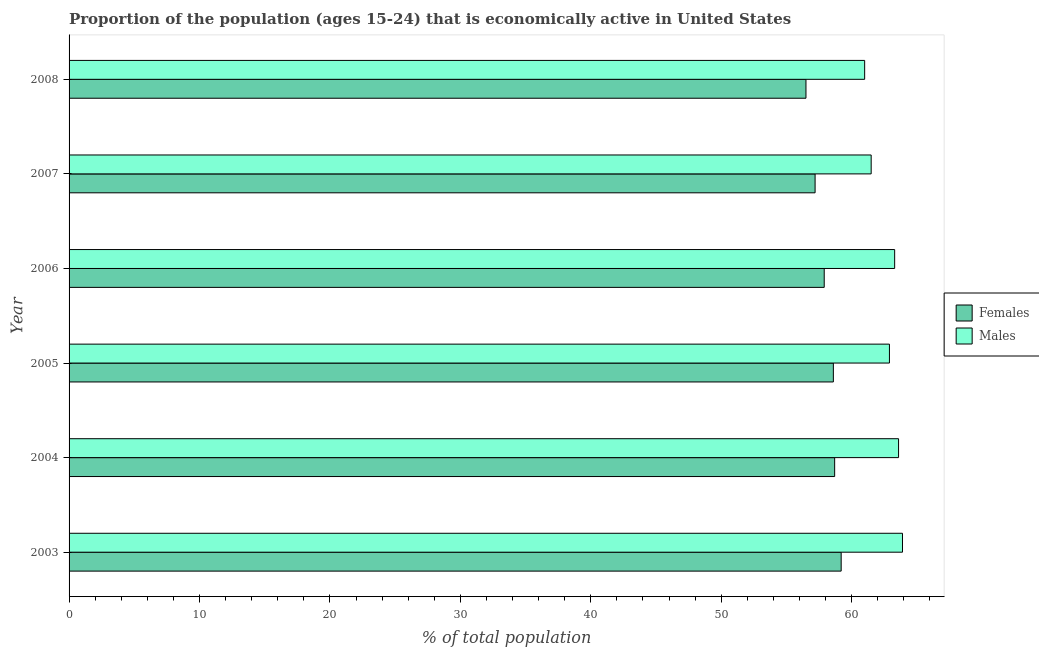How many different coloured bars are there?
Provide a short and direct response. 2. What is the percentage of economically active female population in 2005?
Your response must be concise. 58.6. Across all years, what is the maximum percentage of economically active male population?
Make the answer very short. 63.9. What is the total percentage of economically active female population in the graph?
Provide a succinct answer. 348.1. What is the difference between the percentage of economically active male population in 2006 and that in 2008?
Your response must be concise. 2.3. What is the average percentage of economically active male population per year?
Keep it short and to the point. 62.7. In the year 2006, what is the difference between the percentage of economically active male population and percentage of economically active female population?
Your answer should be compact. 5.4. What is the ratio of the percentage of economically active male population in 2004 to that in 2006?
Make the answer very short. 1. Is the percentage of economically active female population in 2003 less than that in 2005?
Provide a succinct answer. No. What is the difference between the highest and the second highest percentage of economically active female population?
Offer a very short reply. 0.5. What is the difference between the highest and the lowest percentage of economically active female population?
Make the answer very short. 2.7. What does the 1st bar from the top in 2004 represents?
Keep it short and to the point. Males. What does the 2nd bar from the bottom in 2003 represents?
Offer a very short reply. Males. How many bars are there?
Ensure brevity in your answer.  12. Are the values on the major ticks of X-axis written in scientific E-notation?
Your response must be concise. No. What is the title of the graph?
Make the answer very short. Proportion of the population (ages 15-24) that is economically active in United States. Does "Private credit bureau" appear as one of the legend labels in the graph?
Your response must be concise. No. What is the label or title of the X-axis?
Your answer should be compact. % of total population. What is the label or title of the Y-axis?
Ensure brevity in your answer.  Year. What is the % of total population of Females in 2003?
Your response must be concise. 59.2. What is the % of total population of Males in 2003?
Your answer should be very brief. 63.9. What is the % of total population in Females in 2004?
Ensure brevity in your answer.  58.7. What is the % of total population in Males in 2004?
Provide a succinct answer. 63.6. What is the % of total population in Females in 2005?
Offer a terse response. 58.6. What is the % of total population in Males in 2005?
Your answer should be very brief. 62.9. What is the % of total population in Females in 2006?
Your answer should be compact. 57.9. What is the % of total population in Males in 2006?
Provide a short and direct response. 63.3. What is the % of total population of Females in 2007?
Provide a short and direct response. 57.2. What is the % of total population of Males in 2007?
Give a very brief answer. 61.5. What is the % of total population of Females in 2008?
Keep it short and to the point. 56.5. Across all years, what is the maximum % of total population in Females?
Provide a succinct answer. 59.2. Across all years, what is the maximum % of total population of Males?
Your answer should be compact. 63.9. Across all years, what is the minimum % of total population in Females?
Your answer should be compact. 56.5. What is the total % of total population of Females in the graph?
Offer a terse response. 348.1. What is the total % of total population of Males in the graph?
Offer a very short reply. 376.2. What is the difference between the % of total population in Males in 2003 and that in 2004?
Ensure brevity in your answer.  0.3. What is the difference between the % of total population in Males in 2003 and that in 2005?
Your answer should be compact. 1. What is the difference between the % of total population of Females in 2003 and that in 2006?
Provide a short and direct response. 1.3. What is the difference between the % of total population of Males in 2003 and that in 2006?
Your answer should be compact. 0.6. What is the difference between the % of total population in Females in 2003 and that in 2007?
Your answer should be very brief. 2. What is the difference between the % of total population of Males in 2003 and that in 2007?
Provide a short and direct response. 2.4. What is the difference between the % of total population in Males in 2003 and that in 2008?
Your answer should be very brief. 2.9. What is the difference between the % of total population in Females in 2004 and that in 2005?
Your answer should be very brief. 0.1. What is the difference between the % of total population in Males in 2004 and that in 2005?
Your response must be concise. 0.7. What is the difference between the % of total population in Females in 2004 and that in 2007?
Provide a short and direct response. 1.5. What is the difference between the % of total population of Females in 2005 and that in 2008?
Offer a terse response. 2.1. What is the difference between the % of total population in Females in 2006 and that in 2007?
Provide a short and direct response. 0.7. What is the difference between the % of total population in Males in 2006 and that in 2007?
Your answer should be compact. 1.8. What is the difference between the % of total population in Females in 2006 and that in 2008?
Offer a terse response. 1.4. What is the difference between the % of total population of Males in 2007 and that in 2008?
Provide a succinct answer. 0.5. What is the difference between the % of total population of Females in 2003 and the % of total population of Males in 2004?
Your answer should be very brief. -4.4. What is the difference between the % of total population of Females in 2003 and the % of total population of Males in 2006?
Your response must be concise. -4.1. What is the difference between the % of total population in Females in 2003 and the % of total population in Males in 2007?
Ensure brevity in your answer.  -2.3. What is the difference between the % of total population of Females in 2004 and the % of total population of Males in 2005?
Your answer should be compact. -4.2. What is the difference between the % of total population of Females in 2004 and the % of total population of Males in 2007?
Your answer should be compact. -2.8. What is the difference between the % of total population in Females in 2004 and the % of total population in Males in 2008?
Offer a very short reply. -2.3. What is the difference between the % of total population of Females in 2005 and the % of total population of Males in 2006?
Keep it short and to the point. -4.7. What is the difference between the % of total population in Females in 2005 and the % of total population in Males in 2007?
Give a very brief answer. -2.9. What is the difference between the % of total population of Females in 2005 and the % of total population of Males in 2008?
Give a very brief answer. -2.4. What is the difference between the % of total population in Females in 2006 and the % of total population in Males in 2008?
Your answer should be very brief. -3.1. What is the difference between the % of total population of Females in 2007 and the % of total population of Males in 2008?
Give a very brief answer. -3.8. What is the average % of total population in Females per year?
Give a very brief answer. 58.02. What is the average % of total population in Males per year?
Offer a very short reply. 62.7. In the year 2003, what is the difference between the % of total population of Females and % of total population of Males?
Offer a very short reply. -4.7. In the year 2004, what is the difference between the % of total population in Females and % of total population in Males?
Offer a terse response. -4.9. In the year 2008, what is the difference between the % of total population in Females and % of total population in Males?
Offer a terse response. -4.5. What is the ratio of the % of total population of Females in 2003 to that in 2004?
Ensure brevity in your answer.  1.01. What is the ratio of the % of total population of Females in 2003 to that in 2005?
Offer a terse response. 1.01. What is the ratio of the % of total population in Males in 2003 to that in 2005?
Give a very brief answer. 1.02. What is the ratio of the % of total population in Females in 2003 to that in 2006?
Your response must be concise. 1.02. What is the ratio of the % of total population in Males in 2003 to that in 2006?
Your answer should be very brief. 1.01. What is the ratio of the % of total population of Females in 2003 to that in 2007?
Your answer should be very brief. 1.03. What is the ratio of the % of total population in Males in 2003 to that in 2007?
Offer a terse response. 1.04. What is the ratio of the % of total population of Females in 2003 to that in 2008?
Keep it short and to the point. 1.05. What is the ratio of the % of total population of Males in 2003 to that in 2008?
Make the answer very short. 1.05. What is the ratio of the % of total population of Females in 2004 to that in 2005?
Your answer should be very brief. 1. What is the ratio of the % of total population in Males in 2004 to that in 2005?
Your answer should be compact. 1.01. What is the ratio of the % of total population of Females in 2004 to that in 2006?
Offer a very short reply. 1.01. What is the ratio of the % of total population of Males in 2004 to that in 2006?
Offer a very short reply. 1. What is the ratio of the % of total population in Females in 2004 to that in 2007?
Offer a very short reply. 1.03. What is the ratio of the % of total population of Males in 2004 to that in 2007?
Your answer should be very brief. 1.03. What is the ratio of the % of total population of Females in 2004 to that in 2008?
Offer a terse response. 1.04. What is the ratio of the % of total population in Males in 2004 to that in 2008?
Keep it short and to the point. 1.04. What is the ratio of the % of total population in Females in 2005 to that in 2006?
Your response must be concise. 1.01. What is the ratio of the % of total population in Females in 2005 to that in 2007?
Offer a very short reply. 1.02. What is the ratio of the % of total population in Males in 2005 to that in 2007?
Your response must be concise. 1.02. What is the ratio of the % of total population in Females in 2005 to that in 2008?
Keep it short and to the point. 1.04. What is the ratio of the % of total population of Males in 2005 to that in 2008?
Give a very brief answer. 1.03. What is the ratio of the % of total population of Females in 2006 to that in 2007?
Keep it short and to the point. 1.01. What is the ratio of the % of total population of Males in 2006 to that in 2007?
Offer a very short reply. 1.03. What is the ratio of the % of total population in Females in 2006 to that in 2008?
Provide a succinct answer. 1.02. What is the ratio of the % of total population of Males in 2006 to that in 2008?
Ensure brevity in your answer.  1.04. What is the ratio of the % of total population in Females in 2007 to that in 2008?
Your answer should be very brief. 1.01. What is the ratio of the % of total population of Males in 2007 to that in 2008?
Ensure brevity in your answer.  1.01. What is the difference between the highest and the second highest % of total population of Females?
Your answer should be compact. 0.5. What is the difference between the highest and the lowest % of total population in Females?
Offer a very short reply. 2.7. 